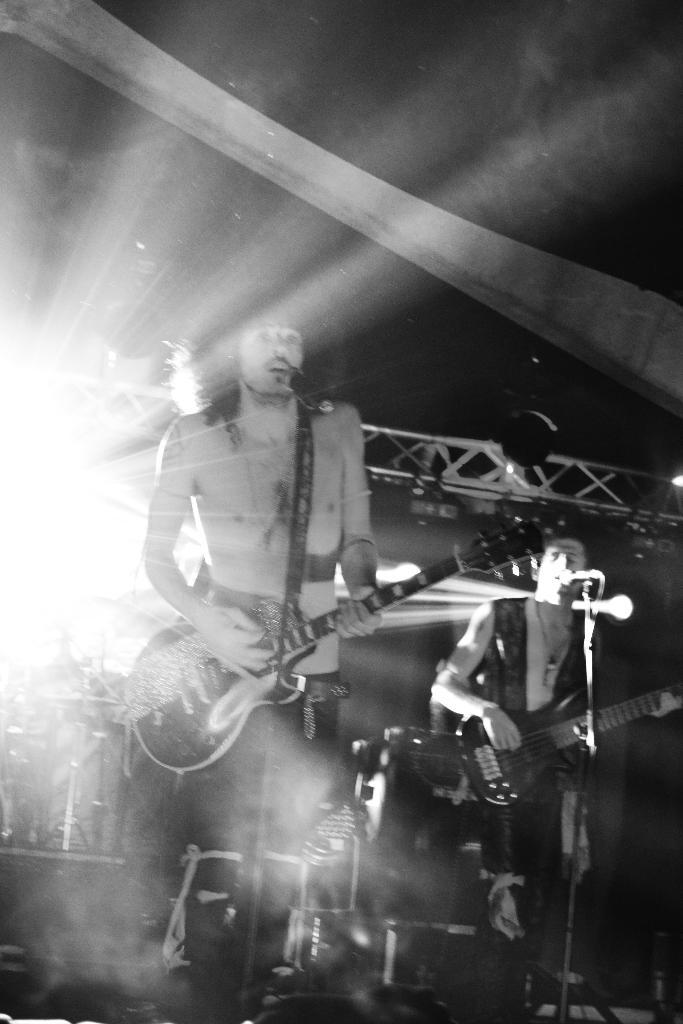What type of picture is in the image? The image contains a black and white picture. Who or what is depicted in the picture? There are people in the picture. What are the people in the picture doing? The people are standing and holding musical instruments. What other objects can be seen in the image? Microphones are present in the image. Can you describe the lighting in the image? There is light visible in the image. What type of brick is being pushed by the people in the image? There is no brick or pushing action depicted in the image; it features people standing and holding musical instruments. 